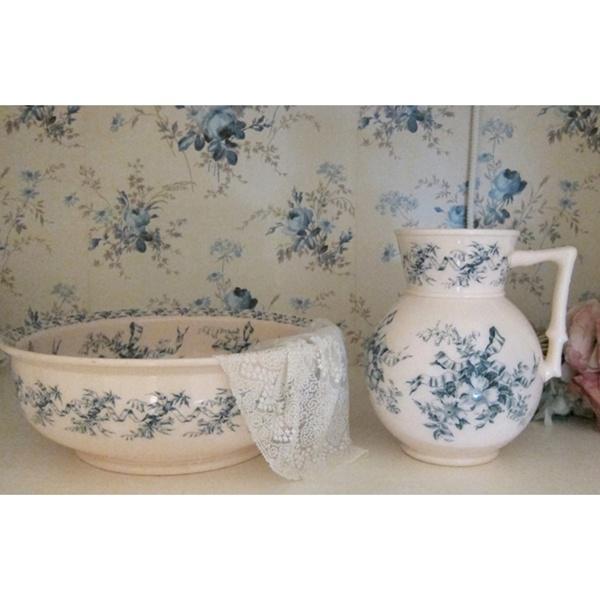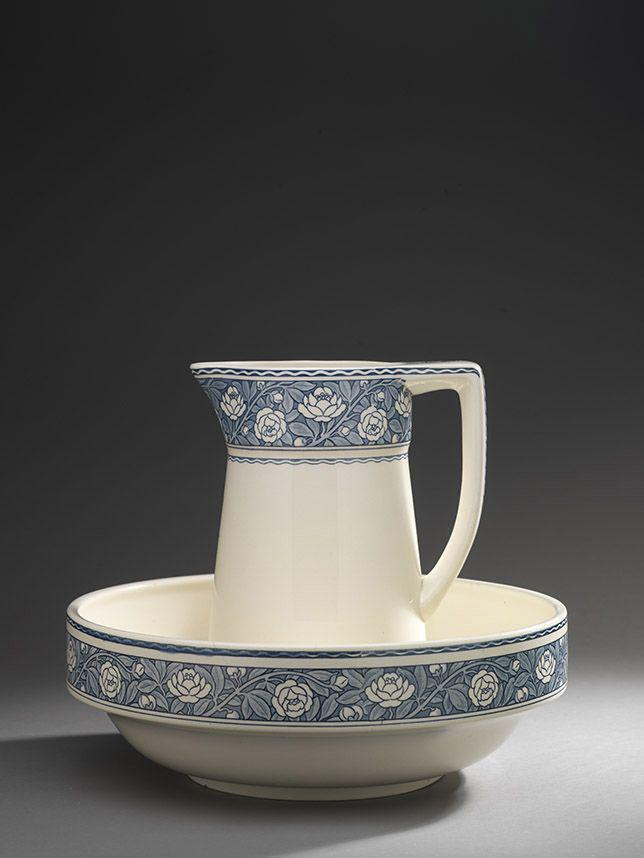The first image is the image on the left, the second image is the image on the right. For the images displayed, is the sentence "At least one image includes a pitcher with a graceful curving handle instead of a squared one." factually correct? Answer yes or no. No. The first image is the image on the left, the second image is the image on the right. Considering the images on both sides, is "One of two bowl and pitcher sets is predominantly white with only a pattern on the upper edge of the pitcher and the bowl." valid? Answer yes or no. Yes. 